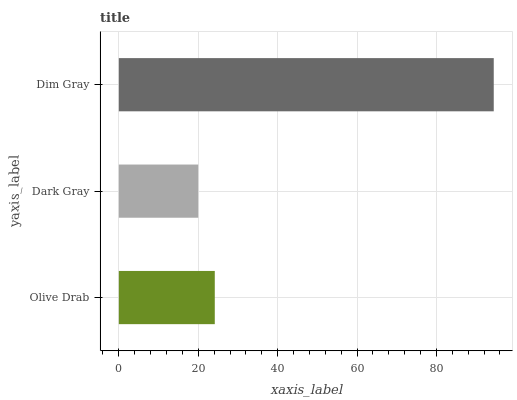Is Dark Gray the minimum?
Answer yes or no. Yes. Is Dim Gray the maximum?
Answer yes or no. Yes. Is Dim Gray the minimum?
Answer yes or no. No. Is Dark Gray the maximum?
Answer yes or no. No. Is Dim Gray greater than Dark Gray?
Answer yes or no. Yes. Is Dark Gray less than Dim Gray?
Answer yes or no. Yes. Is Dark Gray greater than Dim Gray?
Answer yes or no. No. Is Dim Gray less than Dark Gray?
Answer yes or no. No. Is Olive Drab the high median?
Answer yes or no. Yes. Is Olive Drab the low median?
Answer yes or no. Yes. Is Dim Gray the high median?
Answer yes or no. No. Is Dim Gray the low median?
Answer yes or no. No. 